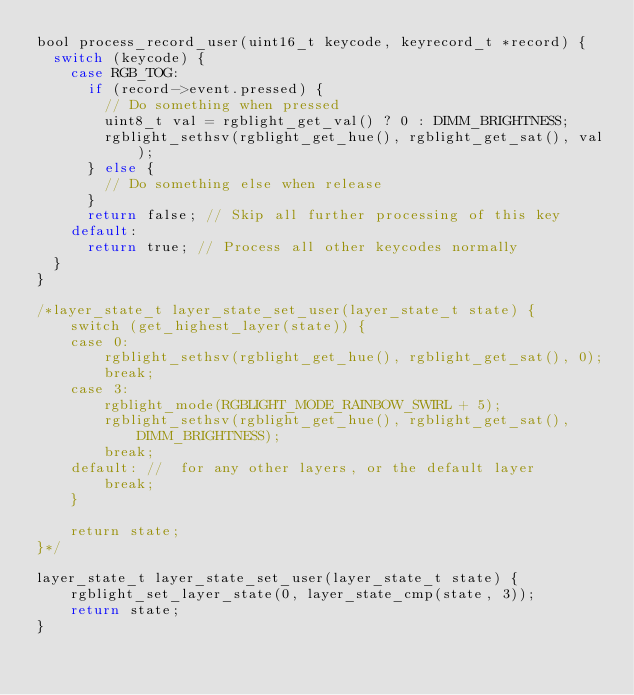<code> <loc_0><loc_0><loc_500><loc_500><_C_>bool process_record_user(uint16_t keycode, keyrecord_t *record) {
  switch (keycode) {
    case RGB_TOG:
      if (record->event.pressed) {
        // Do something when pressed
        uint8_t val = rgblight_get_val() ? 0 : DIMM_BRIGHTNESS;
        rgblight_sethsv(rgblight_get_hue(), rgblight_get_sat(), val);
      } else {
        // Do something else when release
      }
      return false; // Skip all further processing of this key
    default:
      return true; // Process all other keycodes normally
  }
}

/*layer_state_t layer_state_set_user(layer_state_t state) {
    switch (get_highest_layer(state)) {
    case 0:
        rgblight_sethsv(rgblight_get_hue(), rgblight_get_sat(), 0);
        break;
    case 3:
        rgblight_mode(RGBLIGHT_MODE_RAINBOW_SWIRL + 5);
        rgblight_sethsv(rgblight_get_hue(), rgblight_get_sat(), DIMM_BRIGHTNESS);
        break;
    default: //  for any other layers, or the default layer
        break;
    }

    return state;
}*/

layer_state_t layer_state_set_user(layer_state_t state) {
    rgblight_set_layer_state(0, layer_state_cmp(state, 3));
    return state;
}
</code> 